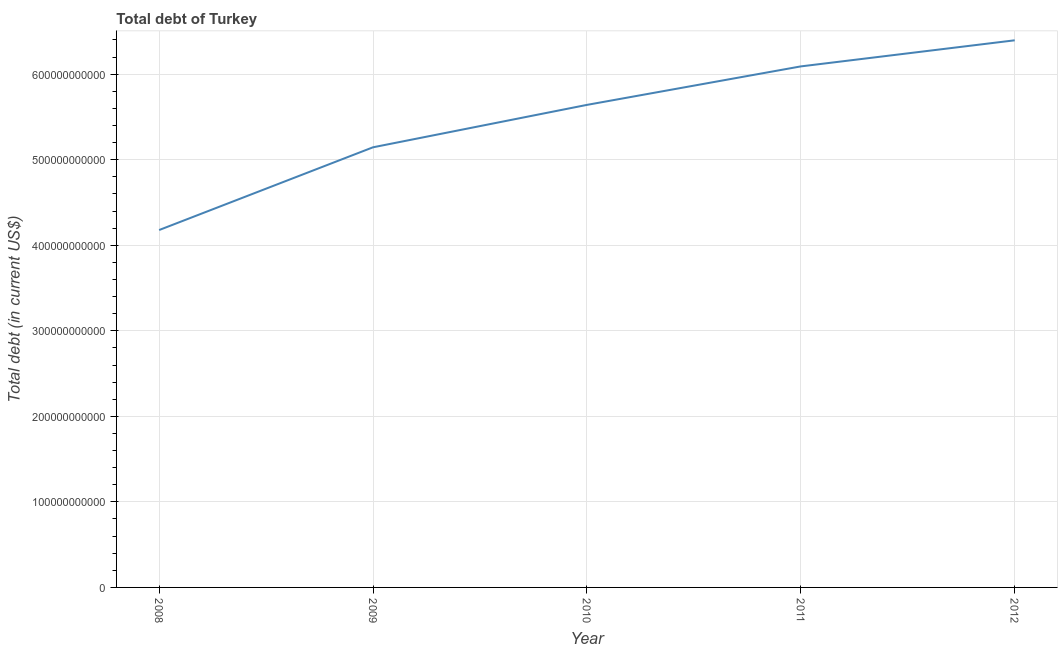What is the total debt in 2008?
Give a very brief answer. 4.18e+11. Across all years, what is the maximum total debt?
Your answer should be compact. 6.40e+11. Across all years, what is the minimum total debt?
Give a very brief answer. 4.18e+11. In which year was the total debt minimum?
Offer a very short reply. 2008. What is the sum of the total debt?
Provide a short and direct response. 2.75e+12. What is the difference between the total debt in 2009 and 2012?
Your response must be concise. -1.25e+11. What is the average total debt per year?
Provide a succinct answer. 5.49e+11. What is the median total debt?
Make the answer very short. 5.64e+11. Do a majority of the years between 2010 and 2012 (inclusive) have total debt greater than 620000000000 US$?
Make the answer very short. No. What is the ratio of the total debt in 2009 to that in 2010?
Make the answer very short. 0.91. Is the difference between the total debt in 2008 and 2010 greater than the difference between any two years?
Make the answer very short. No. What is the difference between the highest and the second highest total debt?
Your answer should be very brief. 3.05e+1. What is the difference between the highest and the lowest total debt?
Keep it short and to the point. 2.22e+11. In how many years, is the total debt greater than the average total debt taken over all years?
Give a very brief answer. 3. Does the total debt monotonically increase over the years?
Offer a terse response. Yes. What is the difference between two consecutive major ticks on the Y-axis?
Make the answer very short. 1.00e+11. Does the graph contain grids?
Offer a terse response. Yes. What is the title of the graph?
Your response must be concise. Total debt of Turkey. What is the label or title of the X-axis?
Provide a short and direct response. Year. What is the label or title of the Y-axis?
Provide a short and direct response. Total debt (in current US$). What is the Total debt (in current US$) in 2008?
Offer a terse response. 4.18e+11. What is the Total debt (in current US$) in 2009?
Your answer should be very brief. 5.15e+11. What is the Total debt (in current US$) in 2010?
Your answer should be very brief. 5.64e+11. What is the Total debt (in current US$) in 2011?
Keep it short and to the point. 6.09e+11. What is the Total debt (in current US$) in 2012?
Keep it short and to the point. 6.40e+11. What is the difference between the Total debt (in current US$) in 2008 and 2009?
Offer a very short reply. -9.67e+1. What is the difference between the Total debt (in current US$) in 2008 and 2010?
Make the answer very short. -1.46e+11. What is the difference between the Total debt (in current US$) in 2008 and 2011?
Give a very brief answer. -1.91e+11. What is the difference between the Total debt (in current US$) in 2008 and 2012?
Your response must be concise. -2.22e+11. What is the difference between the Total debt (in current US$) in 2009 and 2010?
Ensure brevity in your answer.  -4.96e+1. What is the difference between the Total debt (in current US$) in 2009 and 2011?
Your answer should be very brief. -9.46e+1. What is the difference between the Total debt (in current US$) in 2009 and 2012?
Give a very brief answer. -1.25e+11. What is the difference between the Total debt (in current US$) in 2010 and 2011?
Give a very brief answer. -4.50e+1. What is the difference between the Total debt (in current US$) in 2010 and 2012?
Offer a terse response. -7.55e+1. What is the difference between the Total debt (in current US$) in 2011 and 2012?
Make the answer very short. -3.05e+1. What is the ratio of the Total debt (in current US$) in 2008 to that in 2009?
Your answer should be compact. 0.81. What is the ratio of the Total debt (in current US$) in 2008 to that in 2010?
Offer a very short reply. 0.74. What is the ratio of the Total debt (in current US$) in 2008 to that in 2011?
Offer a very short reply. 0.69. What is the ratio of the Total debt (in current US$) in 2008 to that in 2012?
Your answer should be compact. 0.65. What is the ratio of the Total debt (in current US$) in 2009 to that in 2010?
Your answer should be very brief. 0.91. What is the ratio of the Total debt (in current US$) in 2009 to that in 2011?
Offer a very short reply. 0.84. What is the ratio of the Total debt (in current US$) in 2009 to that in 2012?
Your answer should be very brief. 0.8. What is the ratio of the Total debt (in current US$) in 2010 to that in 2011?
Your answer should be very brief. 0.93. What is the ratio of the Total debt (in current US$) in 2010 to that in 2012?
Your answer should be very brief. 0.88. What is the ratio of the Total debt (in current US$) in 2011 to that in 2012?
Your answer should be very brief. 0.95. 